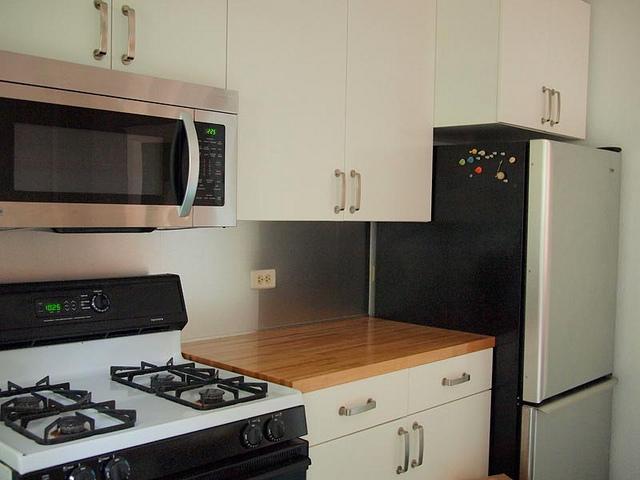What is on the side of the refrigerator?
Keep it brief. Magnets. Is the cabinets open?
Be succinct. No. What color are the knobs?
Keep it brief. Black. Is the clock set to the right time?
Short answer required. Yes. 